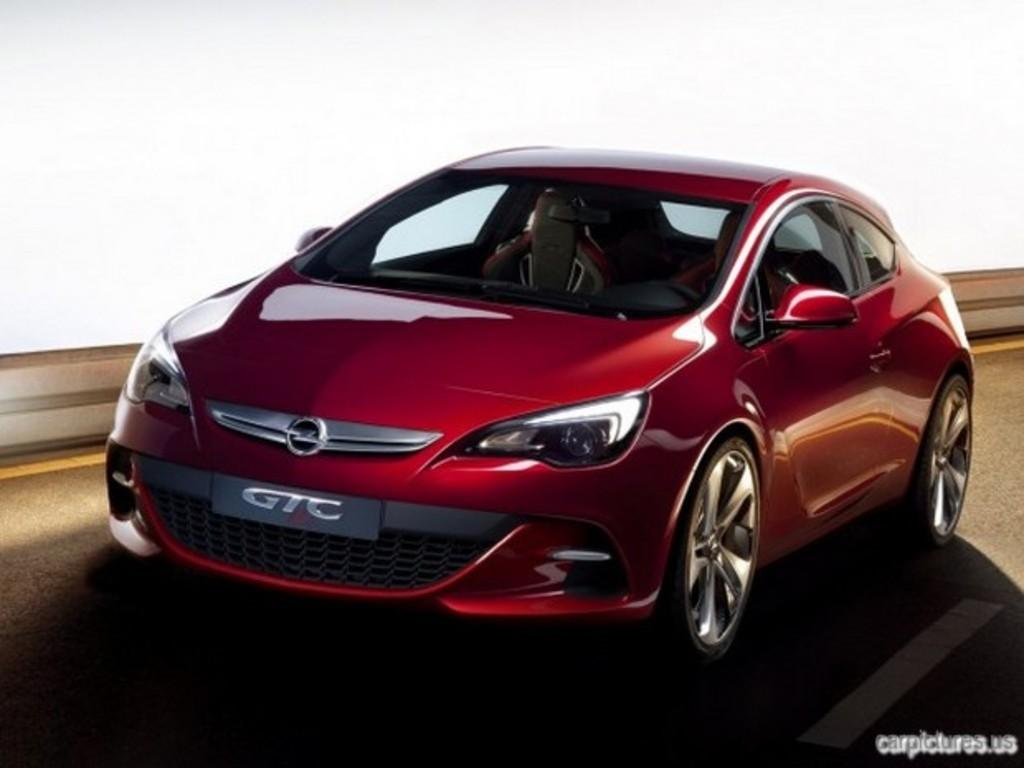What color is the car in the image? The car in the image is red. Can you describe any other details about the car? Unfortunately, the provided facts do not mention any other details about the car. What is located at the right bottom of the image? There is some text at the right bottom of the image. How much income does the tooth in the image generate? There is no tooth present in the image, so it is not possible to determine its income. 